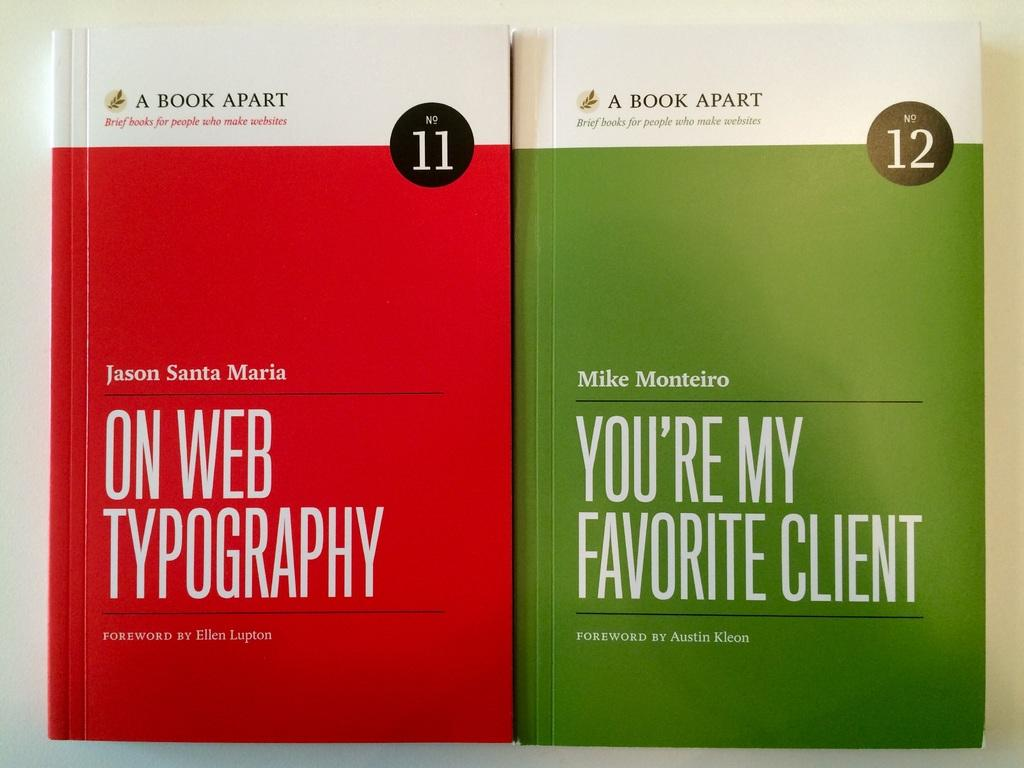<image>
Summarize the visual content of the image. Two books, volume 11 and 12 are next to each other. 